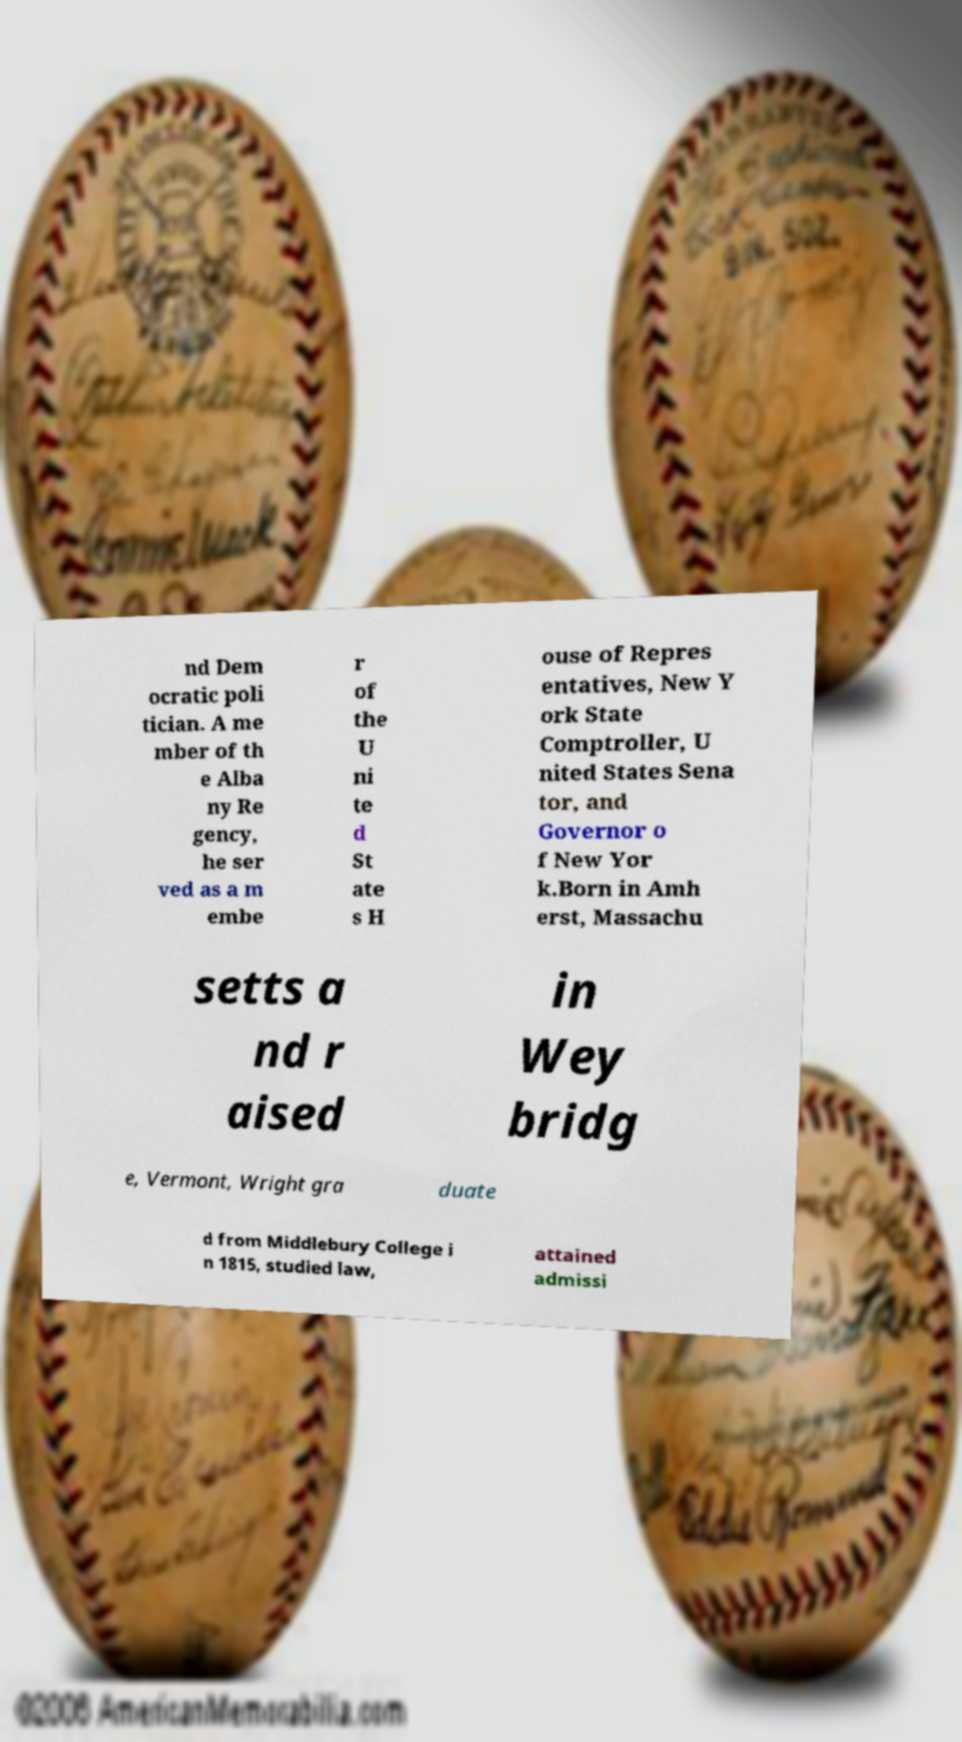Could you assist in decoding the text presented in this image and type it out clearly? nd Dem ocratic poli tician. A me mber of th e Alba ny Re gency, he ser ved as a m embe r of the U ni te d St ate s H ouse of Repres entatives, New Y ork State Comptroller, U nited States Sena tor, and Governor o f New Yor k.Born in Amh erst, Massachu setts a nd r aised in Wey bridg e, Vermont, Wright gra duate d from Middlebury College i n 1815, studied law, attained admissi 